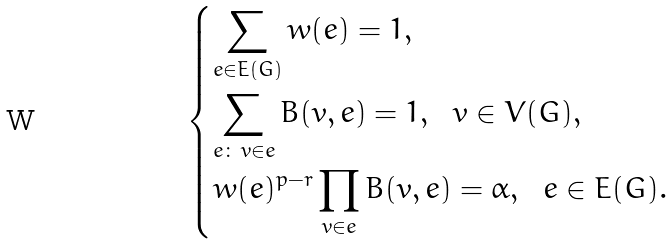<formula> <loc_0><loc_0><loc_500><loc_500>\begin{dcases} \sum _ { e \in E ( G ) } w ( e ) = 1 , \\ \sum _ { e \colon \, v \in e } B ( v , e ) = 1 , \ \ v \in V ( G ) , \\ w ( e ) ^ { p - r } \prod _ { v \in e } B ( v , e ) = \alpha , \ \ e \in E ( G ) . \end{dcases}</formula> 